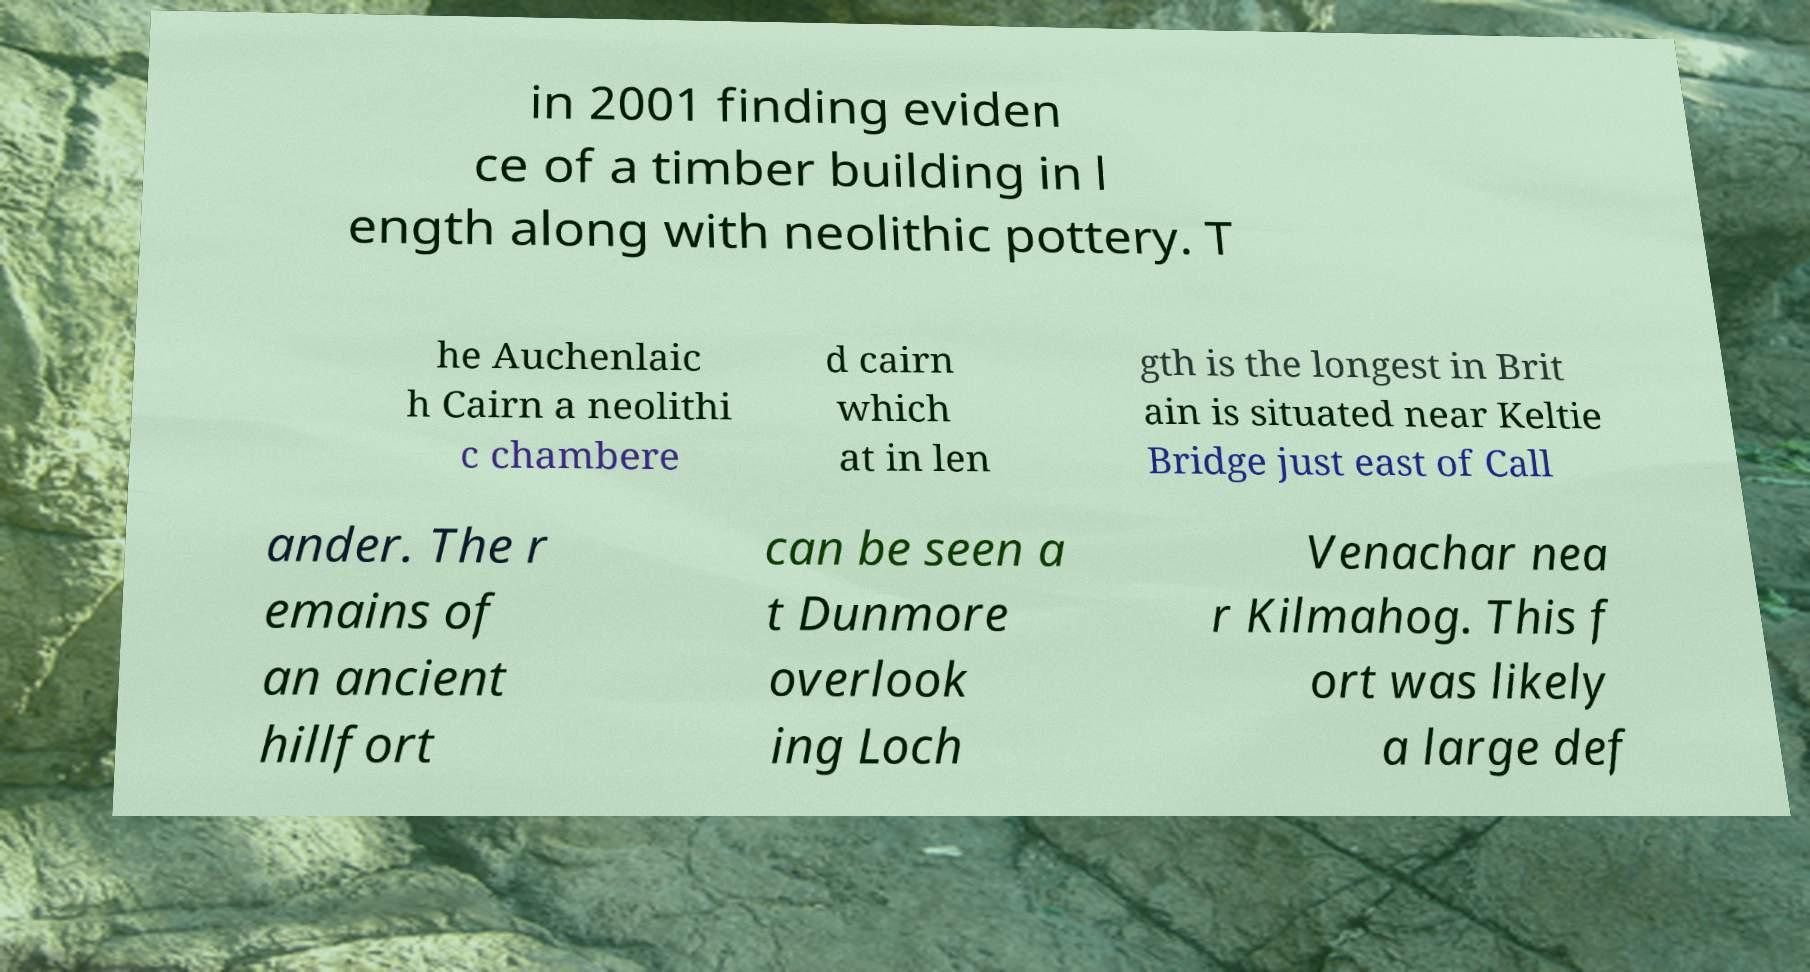What messages or text are displayed in this image? I need them in a readable, typed format. in 2001 finding eviden ce of a timber building in l ength along with neolithic pottery. T he Auchenlaic h Cairn a neolithi c chambere d cairn which at in len gth is the longest in Brit ain is situated near Keltie Bridge just east of Call ander. The r emains of an ancient hillfort can be seen a t Dunmore overlook ing Loch Venachar nea r Kilmahog. This f ort was likely a large def 